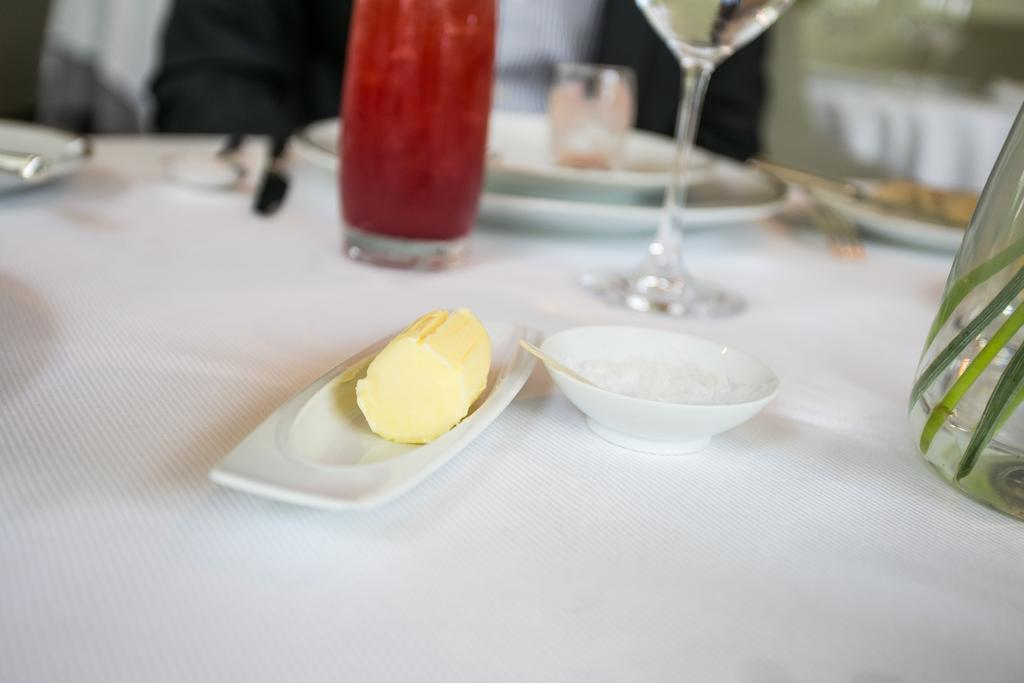What piece of furniture is present in the image? There is a table in the image. What is placed on the table? There is a bowl, a plate, a bottle, a glass, a spoon, and a butter knife on the table. What advice is given on the table in the image? There is no advice present on the table in the image. 